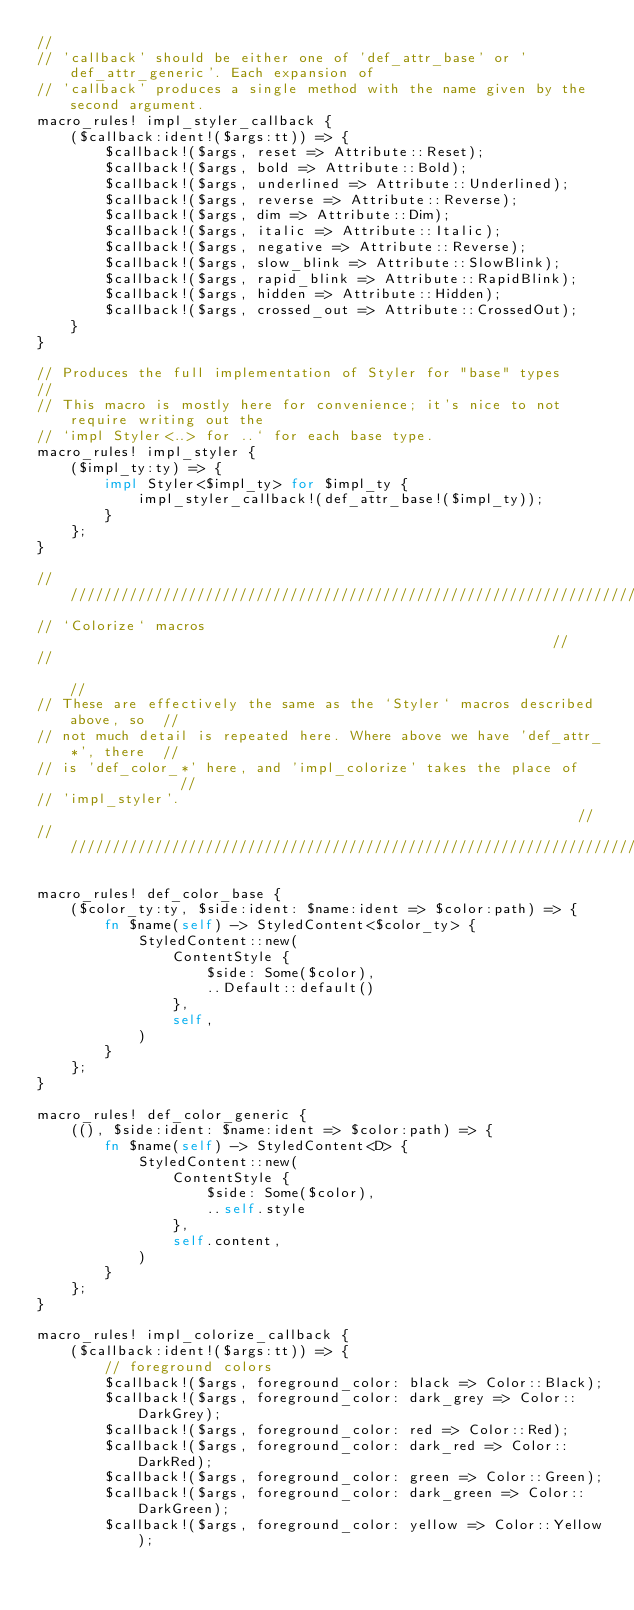Convert code to text. <code><loc_0><loc_0><loc_500><loc_500><_Rust_>//
// 'callback' should be either one of 'def_attr_base' or 'def_attr_generic'. Each expansion of
// 'callback' produces a single method with the name given by the second argument.
macro_rules! impl_styler_callback {
    ($callback:ident!($args:tt)) => {
        $callback!($args, reset => Attribute::Reset);
        $callback!($args, bold => Attribute::Bold);
        $callback!($args, underlined => Attribute::Underlined);
        $callback!($args, reverse => Attribute::Reverse);
        $callback!($args, dim => Attribute::Dim);
        $callback!($args, italic => Attribute::Italic);
        $callback!($args, negative => Attribute::Reverse);
        $callback!($args, slow_blink => Attribute::SlowBlink);
        $callback!($args, rapid_blink => Attribute::RapidBlink);
        $callback!($args, hidden => Attribute::Hidden);
        $callback!($args, crossed_out => Attribute::CrossedOut);
    }
}

// Produces the full implementation of Styler for "base" types
//
// This macro is mostly here for convenience; it's nice to not require writing out the
// `impl Styler<..> for ..` for each base type.
macro_rules! impl_styler {
    ($impl_ty:ty) => {
        impl Styler<$impl_ty> for $impl_ty {
            impl_styler_callback!(def_attr_base!($impl_ty));
        }
    };
}

////////////////////////////////////////////////////////////////////////////////
// `Colorize` macros                                                          //
//                                                                            //
// These are effectively the same as the `Styler` macros described above, so  //
// not much detail is repeated here. Where above we have 'def_attr_*', there  //
// is 'def_color_*' here, and 'impl_colorize' takes the place of              //
// 'impl_styler'.                                                             //
////////////////////////////////////////////////////////////////////////////////

macro_rules! def_color_base {
    ($color_ty:ty, $side:ident: $name:ident => $color:path) => {
        fn $name(self) -> StyledContent<$color_ty> {
            StyledContent::new(
                ContentStyle {
                    $side: Some($color),
                    ..Default::default()
                },
                self,
            )
        }
    };
}

macro_rules! def_color_generic {
    ((), $side:ident: $name:ident => $color:path) => {
        fn $name(self) -> StyledContent<D> {
            StyledContent::new(
                ContentStyle {
                    $side: Some($color),
                    ..self.style
                },
                self.content,
            )
        }
    };
}

macro_rules! impl_colorize_callback {
    ($callback:ident!($args:tt)) => {
        // foreground colors
        $callback!($args, foreground_color: black => Color::Black);
        $callback!($args, foreground_color: dark_grey => Color::DarkGrey);
        $callback!($args, foreground_color: red => Color::Red);
        $callback!($args, foreground_color: dark_red => Color::DarkRed);
        $callback!($args, foreground_color: green => Color::Green);
        $callback!($args, foreground_color: dark_green => Color::DarkGreen);
        $callback!($args, foreground_color: yellow => Color::Yellow);</code> 